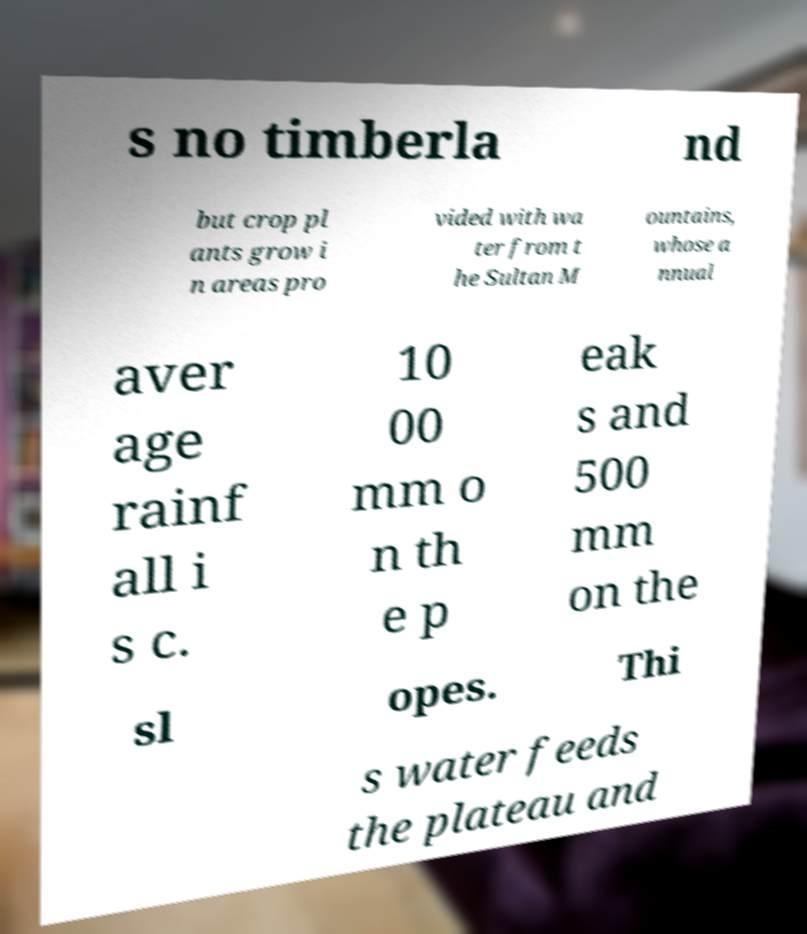Can you accurately transcribe the text from the provided image for me? s no timberla nd but crop pl ants grow i n areas pro vided with wa ter from t he Sultan M ountains, whose a nnual aver age rainf all i s c. 10 00 mm o n th e p eak s and 500 mm on the sl opes. Thi s water feeds the plateau and 